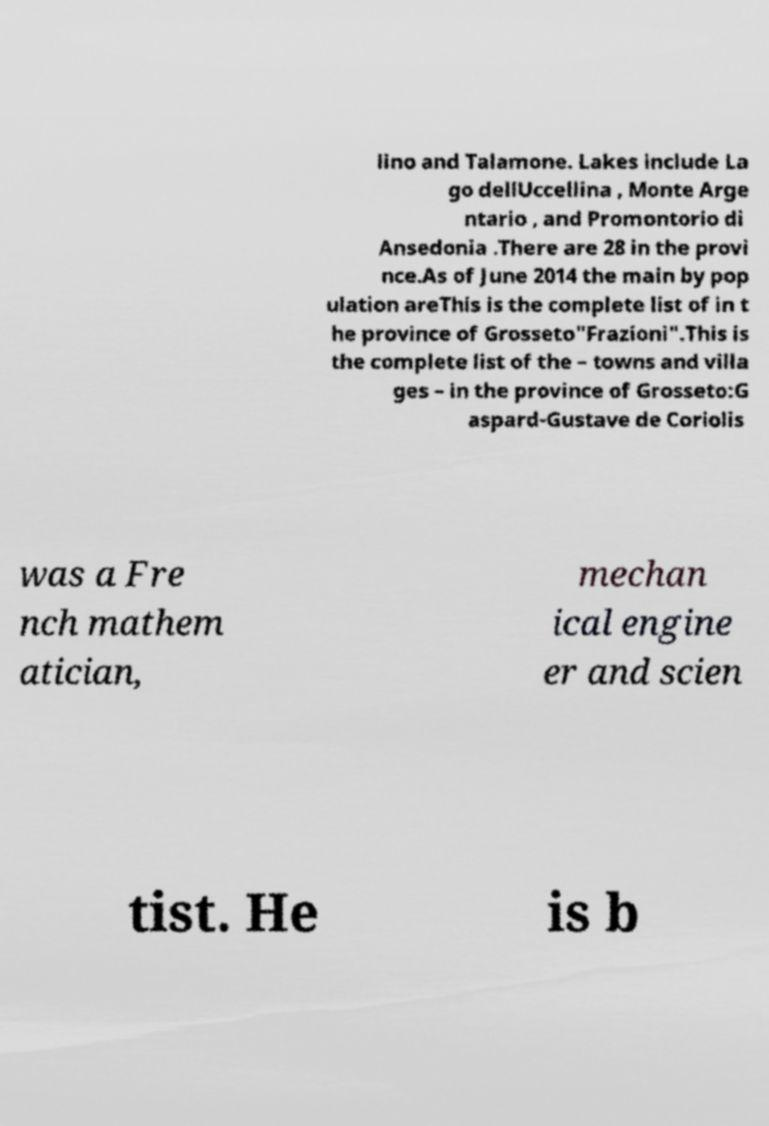For documentation purposes, I need the text within this image transcribed. Could you provide that? lino and Talamone. Lakes include La go dellUccellina , Monte Arge ntario , and Promontorio di Ansedonia .There are 28 in the provi nce.As of June 2014 the main by pop ulation areThis is the complete list of in t he province of Grosseto"Frazioni".This is the complete list of the – towns and villa ges – in the province of Grosseto:G aspard-Gustave de Coriolis was a Fre nch mathem atician, mechan ical engine er and scien tist. He is b 